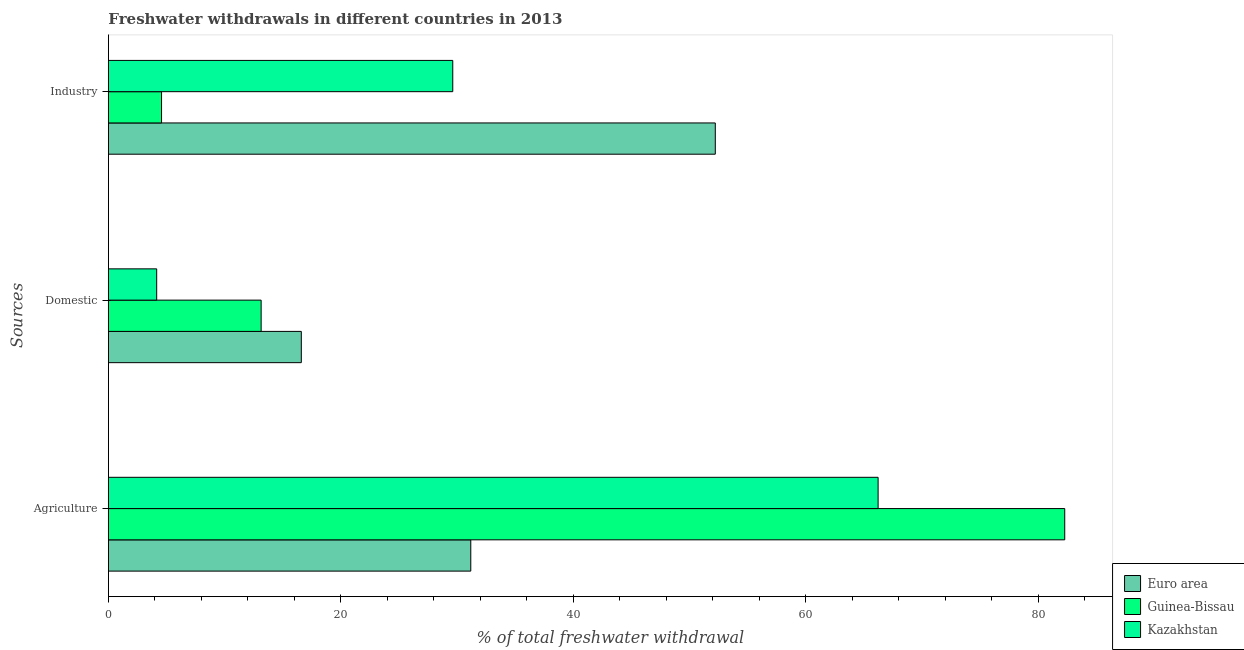How many different coloured bars are there?
Offer a very short reply. 3. How many groups of bars are there?
Ensure brevity in your answer.  3. How many bars are there on the 3rd tick from the bottom?
Give a very brief answer. 3. What is the label of the 2nd group of bars from the top?
Provide a succinct answer. Domestic. What is the percentage of freshwater withdrawal for industry in Guinea-Bissau?
Provide a short and direct response. 4.57. Across all countries, what is the maximum percentage of freshwater withdrawal for industry?
Offer a terse response. 52.22. Across all countries, what is the minimum percentage of freshwater withdrawal for domestic purposes?
Offer a very short reply. 4.15. What is the total percentage of freshwater withdrawal for domestic purposes in the graph?
Keep it short and to the point. 33.89. What is the difference between the percentage of freshwater withdrawal for industry in Kazakhstan and that in Euro area?
Provide a short and direct response. -22.59. What is the difference between the percentage of freshwater withdrawal for agriculture in Guinea-Bissau and the percentage of freshwater withdrawal for industry in Kazakhstan?
Your answer should be very brief. 52.66. What is the average percentage of freshwater withdrawal for agriculture per country?
Offer a terse response. 59.9. What is the difference between the percentage of freshwater withdrawal for agriculture and percentage of freshwater withdrawal for industry in Kazakhstan?
Provide a succinct answer. 36.6. What is the ratio of the percentage of freshwater withdrawal for domestic purposes in Kazakhstan to that in Guinea-Bissau?
Your answer should be compact. 0.32. Is the percentage of freshwater withdrawal for industry in Kazakhstan less than that in Guinea-Bissau?
Provide a short and direct response. No. Is the difference between the percentage of freshwater withdrawal for industry in Euro area and Kazakhstan greater than the difference between the percentage of freshwater withdrawal for agriculture in Euro area and Kazakhstan?
Offer a very short reply. Yes. What is the difference between the highest and the second highest percentage of freshwater withdrawal for industry?
Provide a succinct answer. 22.59. What is the difference between the highest and the lowest percentage of freshwater withdrawal for domestic purposes?
Your response must be concise. 12.44. What does the 2nd bar from the top in Domestic represents?
Provide a succinct answer. Guinea-Bissau. What does the 3rd bar from the bottom in Industry represents?
Your response must be concise. Kazakhstan. Is it the case that in every country, the sum of the percentage of freshwater withdrawal for agriculture and percentage of freshwater withdrawal for domestic purposes is greater than the percentage of freshwater withdrawal for industry?
Ensure brevity in your answer.  No. How many bars are there?
Make the answer very short. 9. Are all the bars in the graph horizontal?
Give a very brief answer. Yes. What is the difference between two consecutive major ticks on the X-axis?
Provide a short and direct response. 20. Are the values on the major ticks of X-axis written in scientific E-notation?
Keep it short and to the point. No. Does the graph contain any zero values?
Offer a very short reply. No. Where does the legend appear in the graph?
Offer a very short reply. Bottom right. What is the title of the graph?
Offer a very short reply. Freshwater withdrawals in different countries in 2013. Does "Rwanda" appear as one of the legend labels in the graph?
Offer a very short reply. No. What is the label or title of the X-axis?
Offer a very short reply. % of total freshwater withdrawal. What is the label or title of the Y-axis?
Your answer should be very brief. Sources. What is the % of total freshwater withdrawal of Euro area in Agriculture?
Your answer should be compact. 31.18. What is the % of total freshwater withdrawal of Guinea-Bissau in Agriculture?
Your answer should be very brief. 82.29. What is the % of total freshwater withdrawal of Kazakhstan in Agriculture?
Your answer should be very brief. 66.23. What is the % of total freshwater withdrawal of Euro area in Domestic?
Keep it short and to the point. 16.6. What is the % of total freshwater withdrawal of Guinea-Bissau in Domestic?
Offer a terse response. 13.14. What is the % of total freshwater withdrawal of Kazakhstan in Domestic?
Offer a terse response. 4.15. What is the % of total freshwater withdrawal of Euro area in Industry?
Your answer should be very brief. 52.22. What is the % of total freshwater withdrawal of Guinea-Bissau in Industry?
Provide a short and direct response. 4.57. What is the % of total freshwater withdrawal in Kazakhstan in Industry?
Your response must be concise. 29.63. Across all Sources, what is the maximum % of total freshwater withdrawal of Euro area?
Make the answer very short. 52.22. Across all Sources, what is the maximum % of total freshwater withdrawal of Guinea-Bissau?
Your response must be concise. 82.29. Across all Sources, what is the maximum % of total freshwater withdrawal of Kazakhstan?
Your answer should be very brief. 66.23. Across all Sources, what is the minimum % of total freshwater withdrawal in Euro area?
Offer a very short reply. 16.6. Across all Sources, what is the minimum % of total freshwater withdrawal of Guinea-Bissau?
Your answer should be compact. 4.57. Across all Sources, what is the minimum % of total freshwater withdrawal of Kazakhstan?
Keep it short and to the point. 4.15. What is the total % of total freshwater withdrawal of Euro area in the graph?
Provide a succinct answer. 100. What is the total % of total freshwater withdrawal in Guinea-Bissau in the graph?
Your answer should be compact. 100. What is the total % of total freshwater withdrawal of Kazakhstan in the graph?
Your answer should be very brief. 100.01. What is the difference between the % of total freshwater withdrawal of Euro area in Agriculture and that in Domestic?
Give a very brief answer. 14.58. What is the difference between the % of total freshwater withdrawal of Guinea-Bissau in Agriculture and that in Domestic?
Make the answer very short. 69.15. What is the difference between the % of total freshwater withdrawal of Kazakhstan in Agriculture and that in Domestic?
Offer a terse response. 62.08. What is the difference between the % of total freshwater withdrawal in Euro area in Agriculture and that in Industry?
Give a very brief answer. -21.04. What is the difference between the % of total freshwater withdrawal in Guinea-Bissau in Agriculture and that in Industry?
Make the answer very short. 77.72. What is the difference between the % of total freshwater withdrawal in Kazakhstan in Agriculture and that in Industry?
Keep it short and to the point. 36.6. What is the difference between the % of total freshwater withdrawal of Euro area in Domestic and that in Industry?
Your answer should be very brief. -35.62. What is the difference between the % of total freshwater withdrawal of Guinea-Bissau in Domestic and that in Industry?
Make the answer very short. 8.57. What is the difference between the % of total freshwater withdrawal in Kazakhstan in Domestic and that in Industry?
Offer a terse response. -25.48. What is the difference between the % of total freshwater withdrawal of Euro area in Agriculture and the % of total freshwater withdrawal of Guinea-Bissau in Domestic?
Give a very brief answer. 18.04. What is the difference between the % of total freshwater withdrawal of Euro area in Agriculture and the % of total freshwater withdrawal of Kazakhstan in Domestic?
Provide a short and direct response. 27.03. What is the difference between the % of total freshwater withdrawal of Guinea-Bissau in Agriculture and the % of total freshwater withdrawal of Kazakhstan in Domestic?
Your answer should be compact. 78.14. What is the difference between the % of total freshwater withdrawal in Euro area in Agriculture and the % of total freshwater withdrawal in Guinea-Bissau in Industry?
Give a very brief answer. 26.61. What is the difference between the % of total freshwater withdrawal in Euro area in Agriculture and the % of total freshwater withdrawal in Kazakhstan in Industry?
Ensure brevity in your answer.  1.55. What is the difference between the % of total freshwater withdrawal of Guinea-Bissau in Agriculture and the % of total freshwater withdrawal of Kazakhstan in Industry?
Provide a short and direct response. 52.66. What is the difference between the % of total freshwater withdrawal of Euro area in Domestic and the % of total freshwater withdrawal of Guinea-Bissau in Industry?
Your answer should be very brief. 12.03. What is the difference between the % of total freshwater withdrawal in Euro area in Domestic and the % of total freshwater withdrawal in Kazakhstan in Industry?
Offer a very short reply. -13.03. What is the difference between the % of total freshwater withdrawal of Guinea-Bissau in Domestic and the % of total freshwater withdrawal of Kazakhstan in Industry?
Your answer should be very brief. -16.49. What is the average % of total freshwater withdrawal in Euro area per Sources?
Make the answer very short. 33.33. What is the average % of total freshwater withdrawal in Guinea-Bissau per Sources?
Keep it short and to the point. 33.33. What is the average % of total freshwater withdrawal in Kazakhstan per Sources?
Give a very brief answer. 33.34. What is the difference between the % of total freshwater withdrawal in Euro area and % of total freshwater withdrawal in Guinea-Bissau in Agriculture?
Make the answer very short. -51.11. What is the difference between the % of total freshwater withdrawal of Euro area and % of total freshwater withdrawal of Kazakhstan in Agriculture?
Ensure brevity in your answer.  -35.05. What is the difference between the % of total freshwater withdrawal of Guinea-Bissau and % of total freshwater withdrawal of Kazakhstan in Agriculture?
Offer a terse response. 16.06. What is the difference between the % of total freshwater withdrawal of Euro area and % of total freshwater withdrawal of Guinea-Bissau in Domestic?
Your answer should be compact. 3.46. What is the difference between the % of total freshwater withdrawal in Euro area and % of total freshwater withdrawal in Kazakhstan in Domestic?
Ensure brevity in your answer.  12.44. What is the difference between the % of total freshwater withdrawal in Guinea-Bissau and % of total freshwater withdrawal in Kazakhstan in Domestic?
Give a very brief answer. 8.99. What is the difference between the % of total freshwater withdrawal of Euro area and % of total freshwater withdrawal of Guinea-Bissau in Industry?
Your answer should be compact. 47.65. What is the difference between the % of total freshwater withdrawal in Euro area and % of total freshwater withdrawal in Kazakhstan in Industry?
Your answer should be very brief. 22.59. What is the difference between the % of total freshwater withdrawal in Guinea-Bissau and % of total freshwater withdrawal in Kazakhstan in Industry?
Make the answer very short. -25.06. What is the ratio of the % of total freshwater withdrawal in Euro area in Agriculture to that in Domestic?
Your answer should be compact. 1.88. What is the ratio of the % of total freshwater withdrawal in Guinea-Bissau in Agriculture to that in Domestic?
Keep it short and to the point. 6.26. What is the ratio of the % of total freshwater withdrawal in Kazakhstan in Agriculture to that in Domestic?
Ensure brevity in your answer.  15.95. What is the ratio of the % of total freshwater withdrawal in Euro area in Agriculture to that in Industry?
Provide a short and direct response. 0.6. What is the ratio of the % of total freshwater withdrawal in Guinea-Bissau in Agriculture to that in Industry?
Give a very brief answer. 18. What is the ratio of the % of total freshwater withdrawal in Kazakhstan in Agriculture to that in Industry?
Provide a short and direct response. 2.24. What is the ratio of the % of total freshwater withdrawal of Euro area in Domestic to that in Industry?
Ensure brevity in your answer.  0.32. What is the ratio of the % of total freshwater withdrawal of Guinea-Bissau in Domestic to that in Industry?
Offer a very short reply. 2.87. What is the ratio of the % of total freshwater withdrawal in Kazakhstan in Domestic to that in Industry?
Make the answer very short. 0.14. What is the difference between the highest and the second highest % of total freshwater withdrawal of Euro area?
Provide a short and direct response. 21.04. What is the difference between the highest and the second highest % of total freshwater withdrawal in Guinea-Bissau?
Provide a short and direct response. 69.15. What is the difference between the highest and the second highest % of total freshwater withdrawal of Kazakhstan?
Your response must be concise. 36.6. What is the difference between the highest and the lowest % of total freshwater withdrawal in Euro area?
Ensure brevity in your answer.  35.62. What is the difference between the highest and the lowest % of total freshwater withdrawal of Guinea-Bissau?
Ensure brevity in your answer.  77.72. What is the difference between the highest and the lowest % of total freshwater withdrawal in Kazakhstan?
Keep it short and to the point. 62.08. 